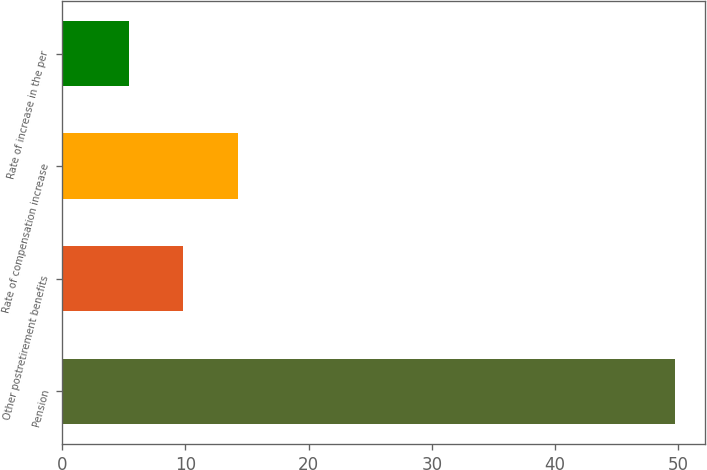<chart> <loc_0><loc_0><loc_500><loc_500><bar_chart><fcel>Pension<fcel>Other postretirement benefits<fcel>Rate of compensation increase<fcel>Rate of increase in the per<nl><fcel>49.7<fcel>9.83<fcel>14.26<fcel>5.4<nl></chart> 